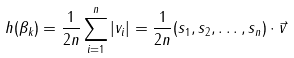Convert formula to latex. <formula><loc_0><loc_0><loc_500><loc_500>h ( \beta _ { k } ) = \frac { 1 } { 2 n } \sum _ { i = 1 } ^ { n } \left | v _ { i } \right | = \frac { 1 } { 2 n } ( s _ { 1 } , s _ { 2 } , \dots , s _ { n } ) \cdot \vec { v }</formula> 